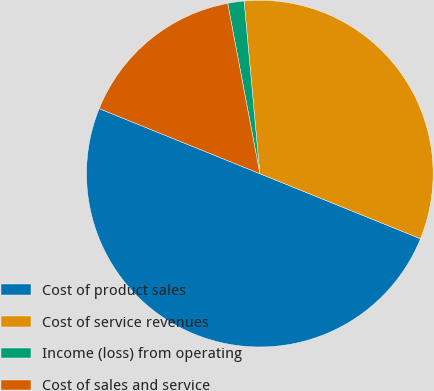<chart> <loc_0><loc_0><loc_500><loc_500><pie_chart><fcel>Cost of product sales<fcel>Cost of service revenues<fcel>Income (loss) from operating<fcel>Cost of sales and service<nl><fcel>50.0%<fcel>32.58%<fcel>1.52%<fcel>15.91%<nl></chart> 